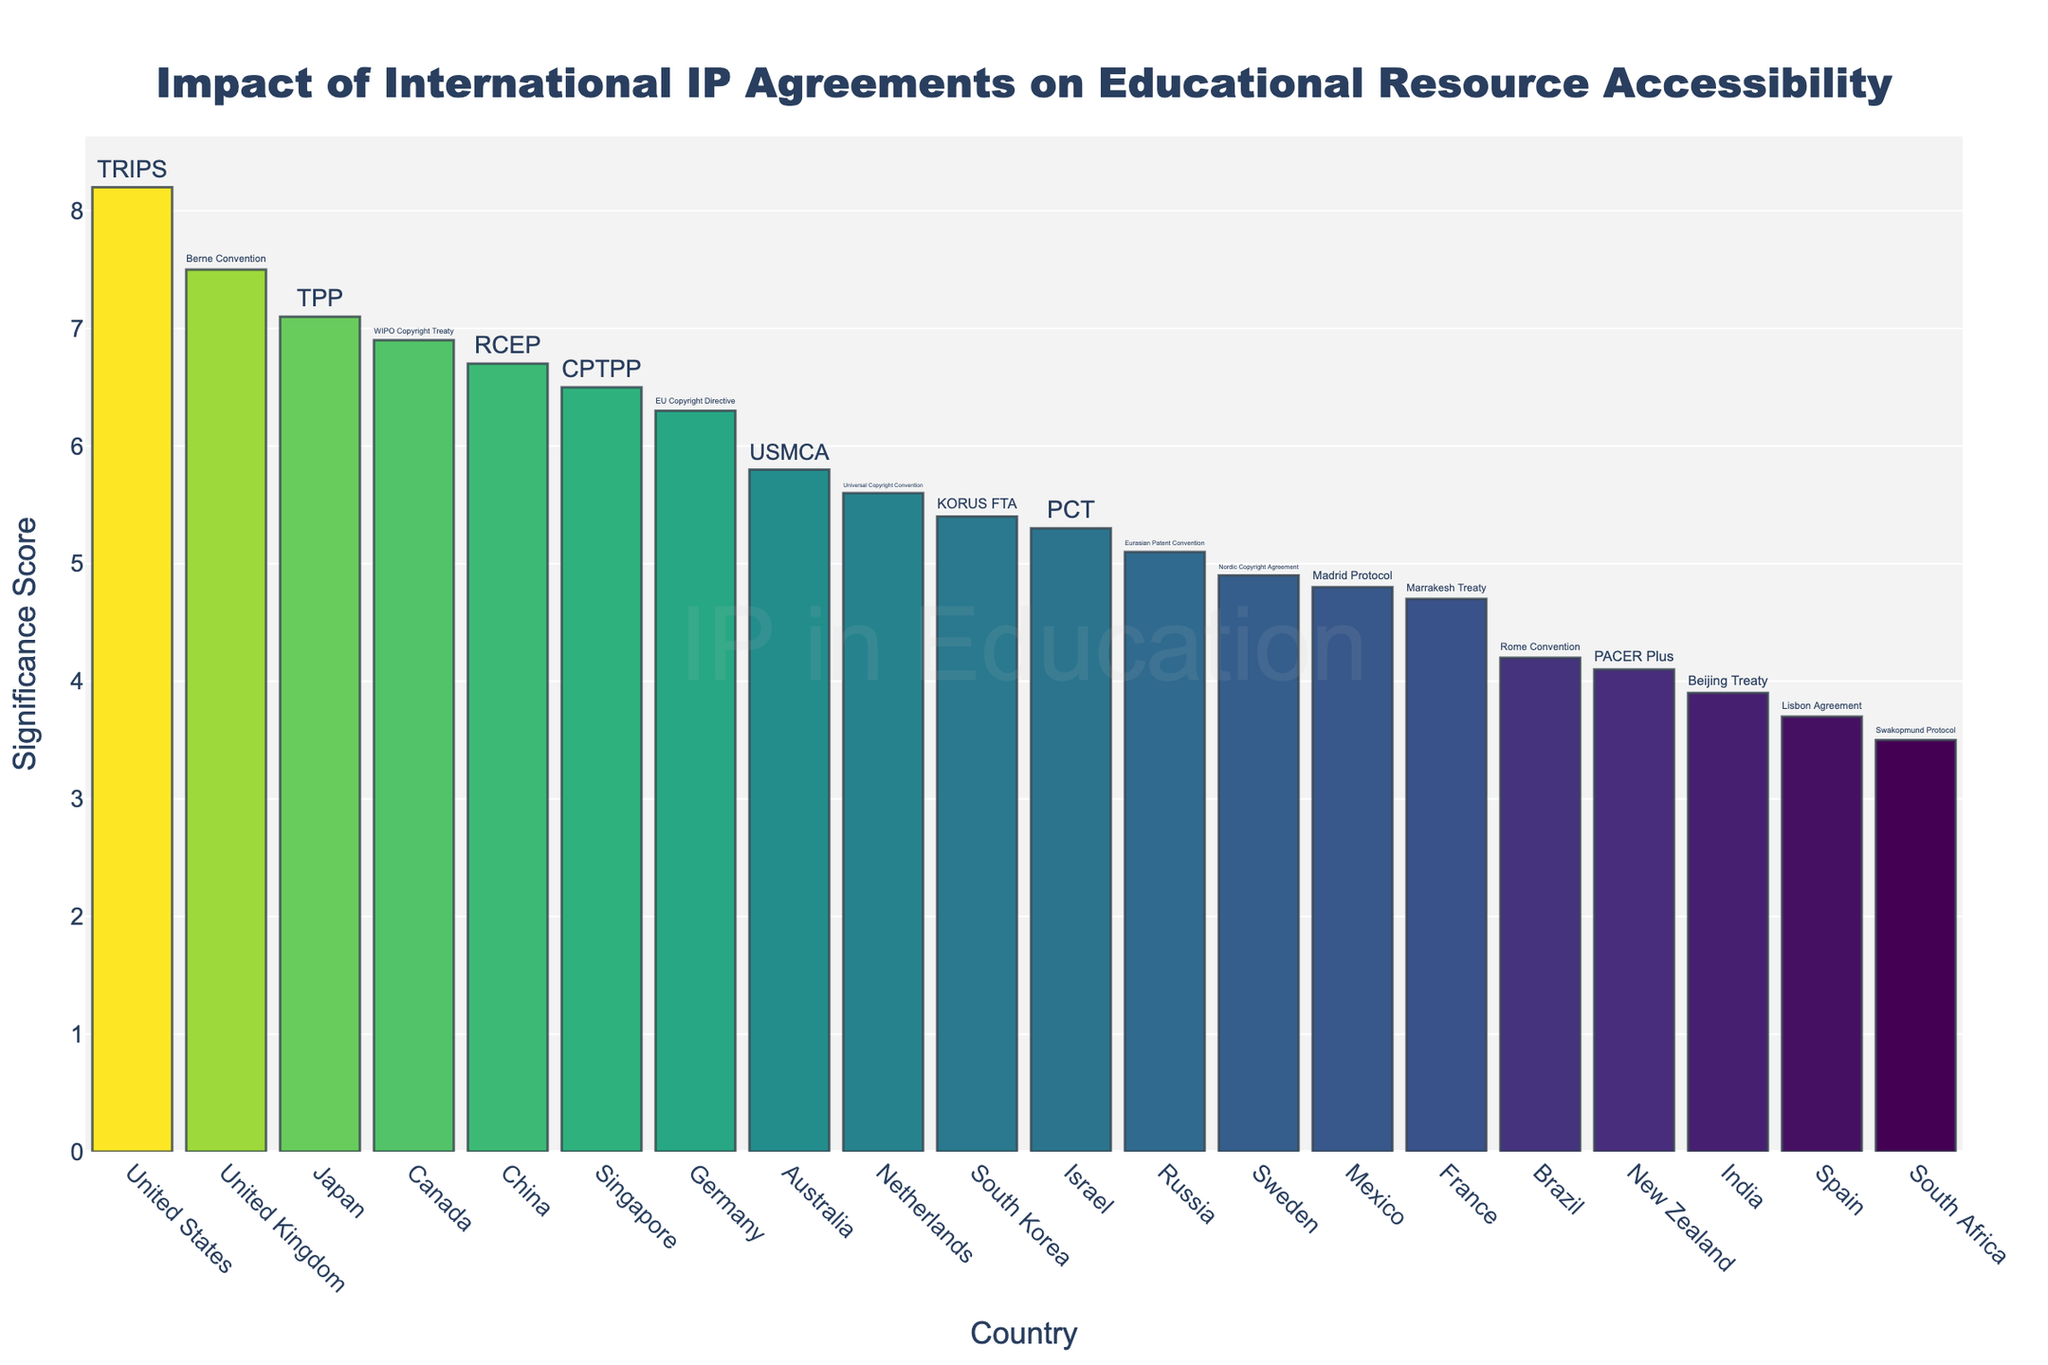What's the title of the figure? The title of the figure is displayed at the top. It indicates the topic of the analysis.
Answer: Impact of International IP Agreements on Educational Resource Accessibility How many countries are included in the figure? By counting the number of bars in the figure, which represent the countries, we can determine the number of countries included.
Answer: 20 Which country has the highest significance score? Look for the tallest bar in the figure as it represents the country with the highest significance score.
Answer: United States What is the significance score for Mexico? Locate the bar labeled 'Mexico' and read the y-axis value for that bar.
Answer: 4.8 Which international agreement is associated with Canada? By hovering over the bar for Canada or reading the text displayed on it, we can identify the associated agreement.
Answer: WIPO Copyright Treaty What's the sum of the significance scores for China and Japan? Find the scores for China and Japan, add them together. (China: 6.7, Japan: 7.1)
Answer: 13.8 Which country has a higher significance score, Germany or Singapore? Compare the heights of the bars for Germany and Singapore to see which is taller.
Answer: Singapore How many countries have a significance score above 5? Count the number of bars with their y-axis value above 5.
Answer: 10 What's the median significance score of all the countries? List all significance scores in order, and find the middle value. Since there are 20 countries, the median is the average of the 10th and 11th values. (5.8 + 6.3) / 2
Answer: 6.05 Which country has the lowest significance score, and what is its value? Identify the shortest bar and read the corresponding country label and y-axis value.
Answer: South Africa, 3.5 